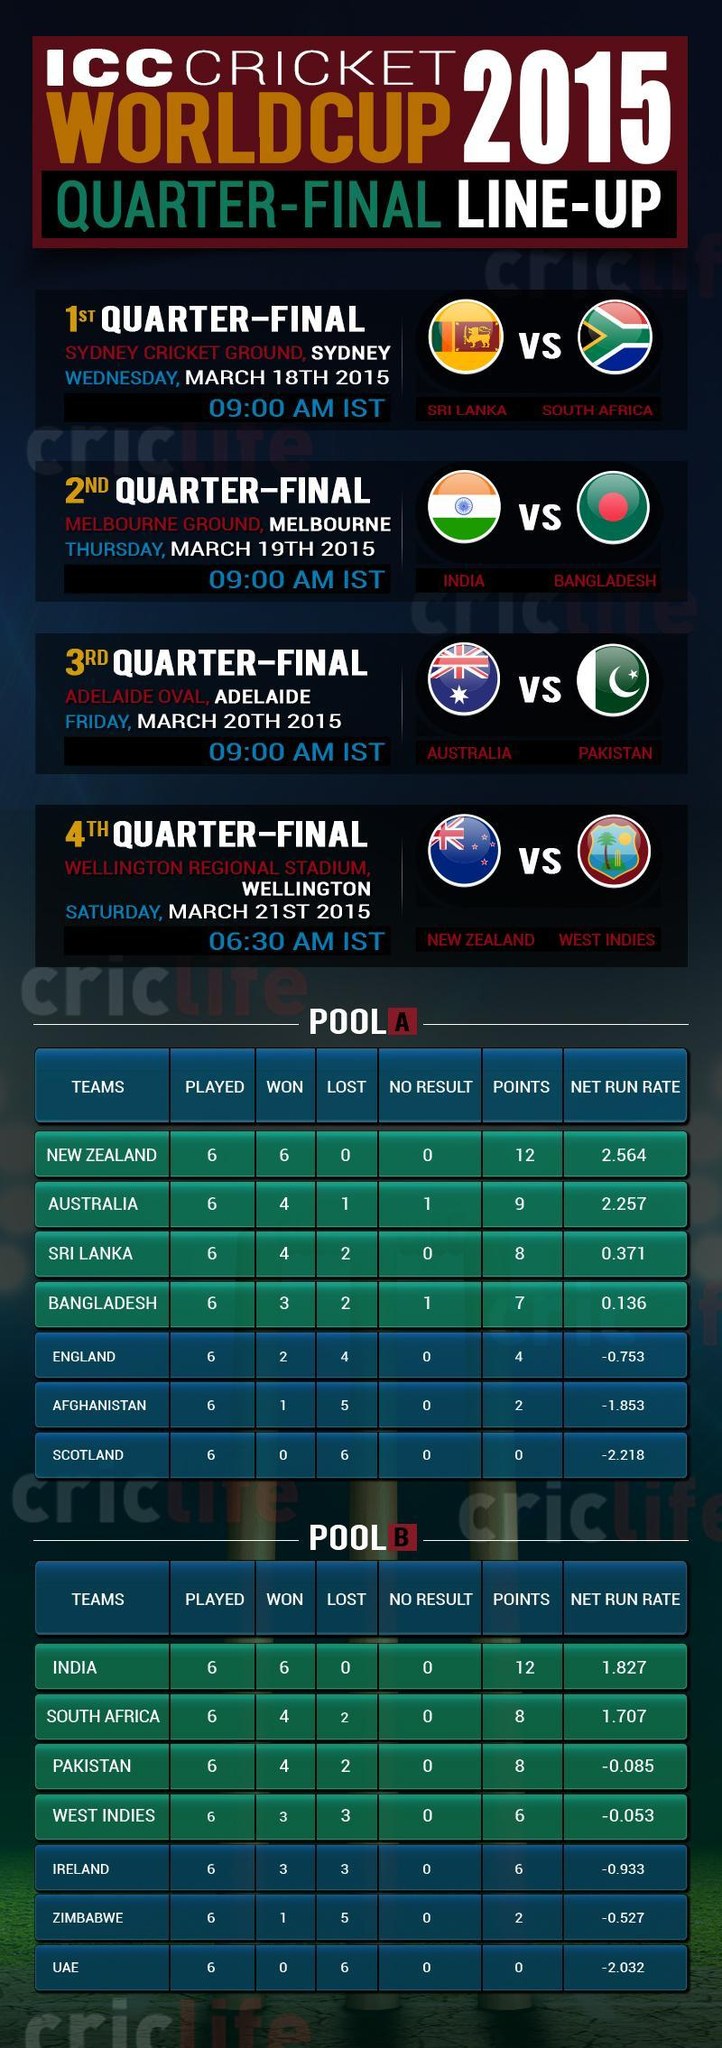Adelaide Oval will the venue for the match between which two teams?
Answer the question with a short phrase. Australia, Pakistan Which is the venue for the match between Sri Lanka and South Africa? Sydney How many teams in Pool B has 8 points? 2 Which team is at second position in Pool B? South Africa In which match will India play against Bangladesh? 2nd Quarter-Final Australia will play against Pakistan in which match? 3rd Quarter-Final Which team is at third position in Pool A? Sri Lanka Which is the venue for the match between New Zealand and West Indies? Wellington Regional Stadium, Wellington Which team in Pool B has 12 points? India Between which teams is the 1st quarter final match scheduled? Sri Lanka, South Africa 